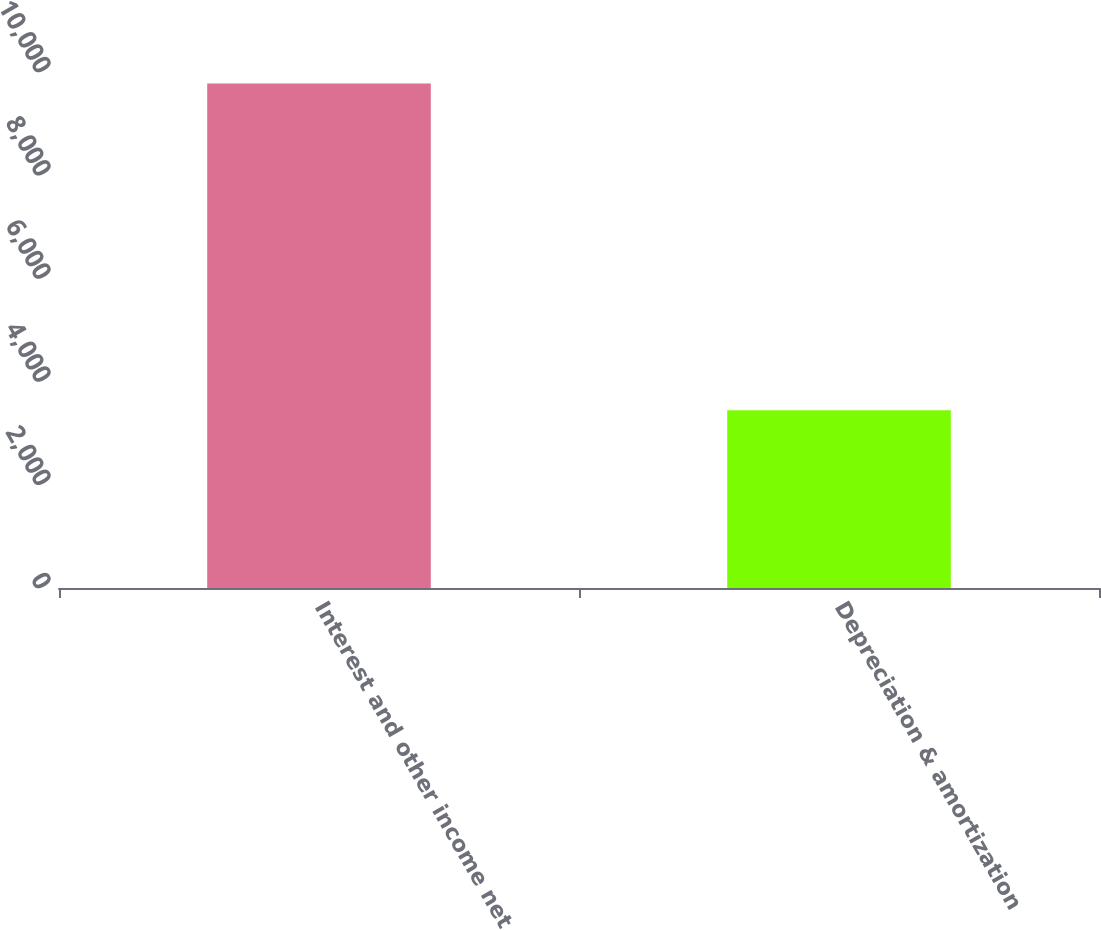Convert chart. <chart><loc_0><loc_0><loc_500><loc_500><bar_chart><fcel>Interest and other income net<fcel>Depreciation & amortization<nl><fcel>9775<fcel>3446<nl></chart> 